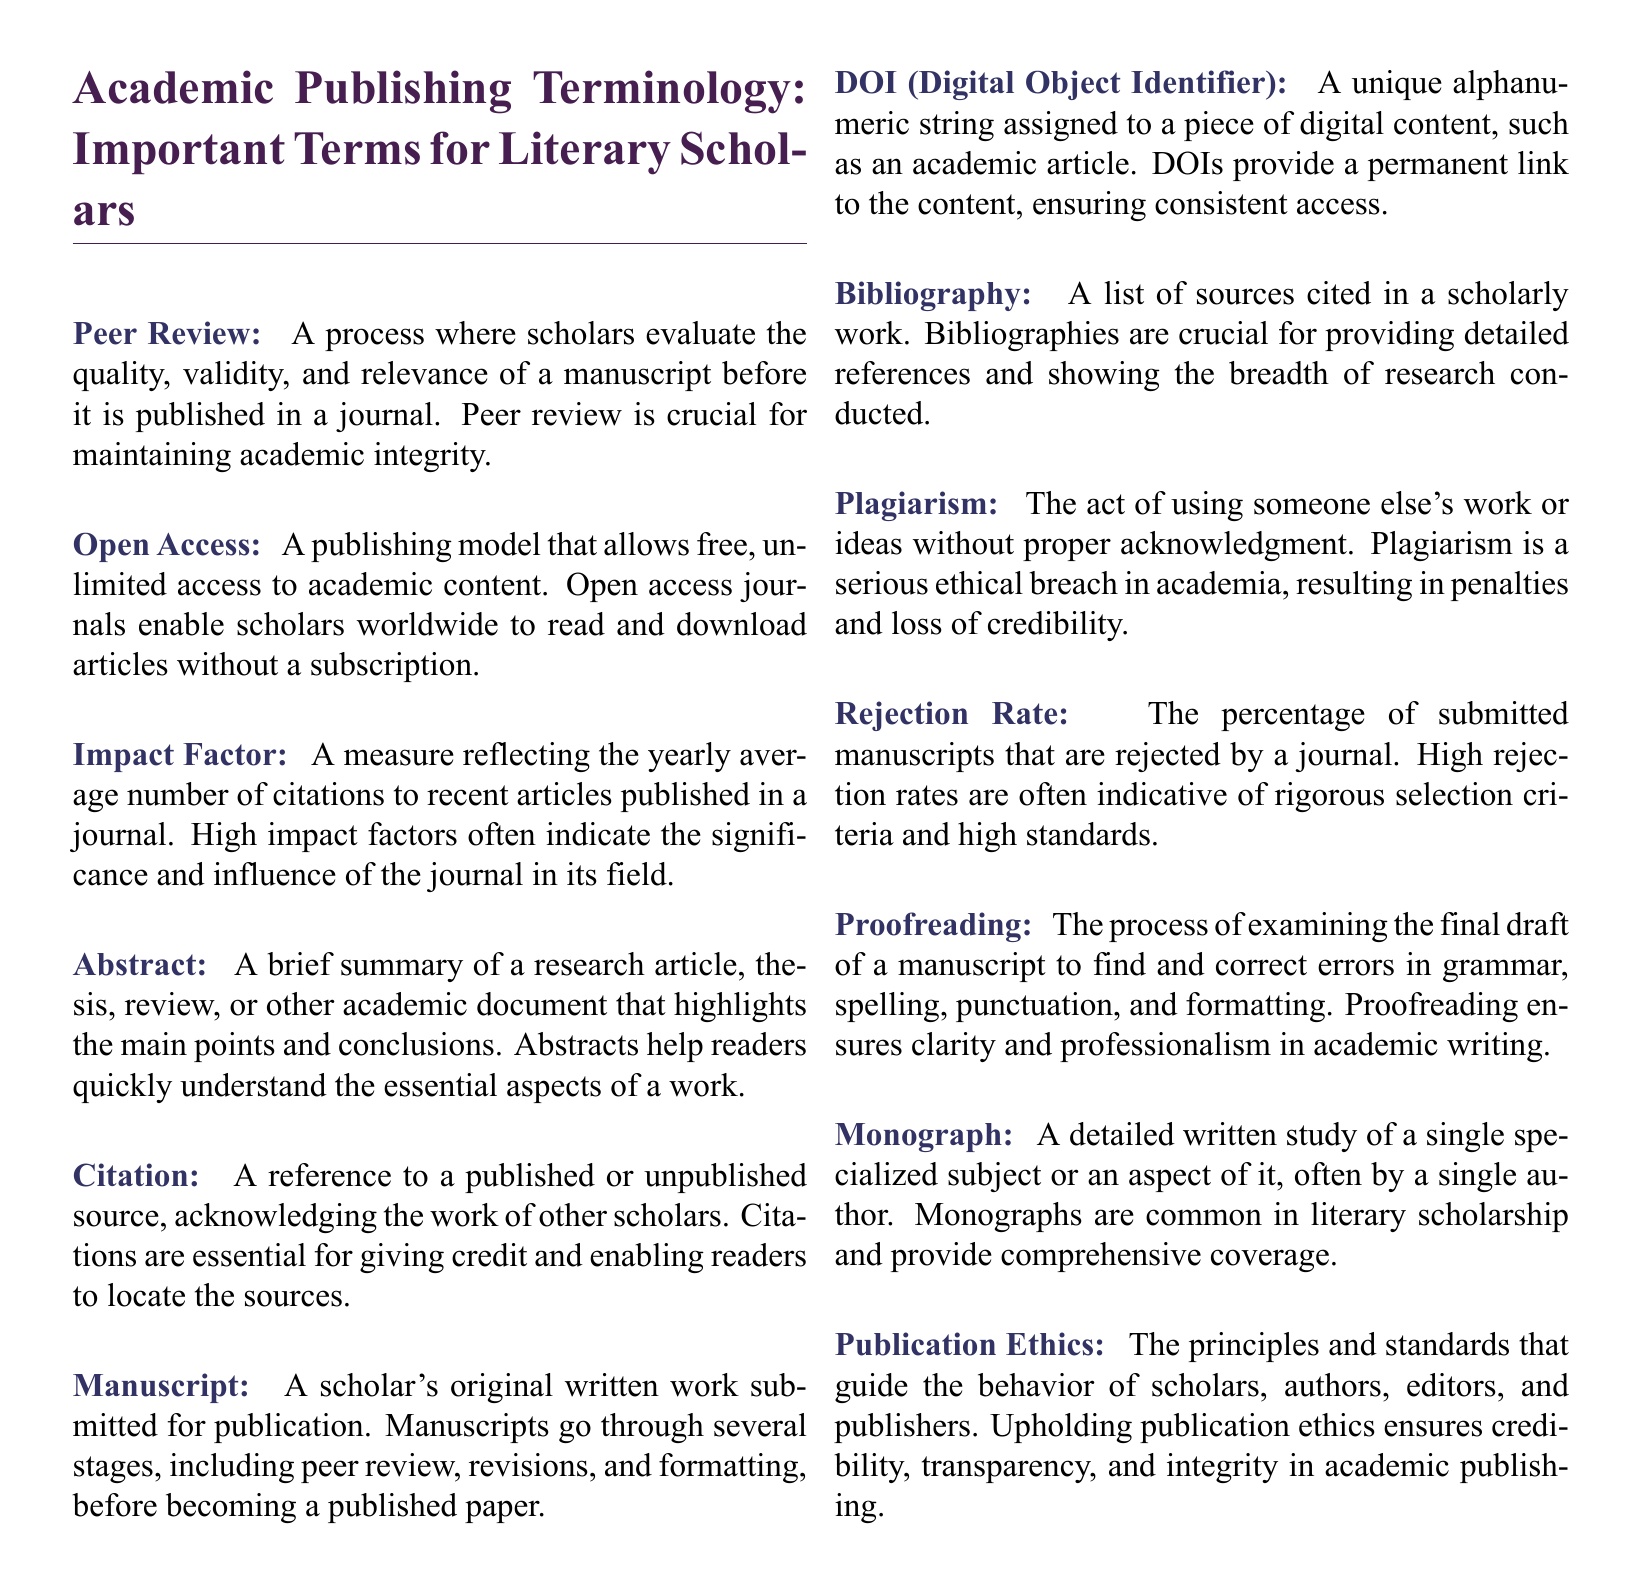what is peer review? Peer review is a process where scholars evaluate the quality, validity, and relevance of a manuscript before it is published in a journal.
Answer: process where scholars evaluate the quality, validity, and relevance of a manuscript what does open access mean? Open access is a publishing model that allows free, unlimited access to academic content.
Answer: free, unlimited access to academic content what is the impact factor? The impact factor is a measure reflecting the yearly average number of citations to recent articles published in a journal.
Answer: measure reflecting the yearly average number of citations what is a manuscript? A manuscript is a scholar's original written work submitted for publication.
Answer: original written work submitted for publication what is plagiarism? Plagiarism is the act of using someone else's work or ideas without proper acknowledgment.
Answer: using someone else's work or ideas without proper acknowledgment how is the rejection rate relevant to a journal? The rejection rate indicates the percentage of submitted manuscripts that are rejected by a journal, reflecting its selection criteria.
Answer: percentage of submitted manuscripts that are rejected what is the purpose of proofreading? Proofreading is the process of examining the final draft of a manuscript to find and correct errors.
Answer: examining the final draft of a manuscript to find and correct errors how does a DOI function in academic publishing? A DOI provides a permanent link to digital content, ensuring consistent access.
Answer: provides a permanent link to digital content how is a bibliography defined in scholarly work? A bibliography is a list of sources cited in a scholarly work.
Answer: list of sources cited in a scholarly work what do publication ethics entail? Publication ethics entails the principles and standards that guide the behavior of scholars, authors, editors, and publishers.
Answer: principles and standards that guide behavior of scholars, authors, editors, and publishers 